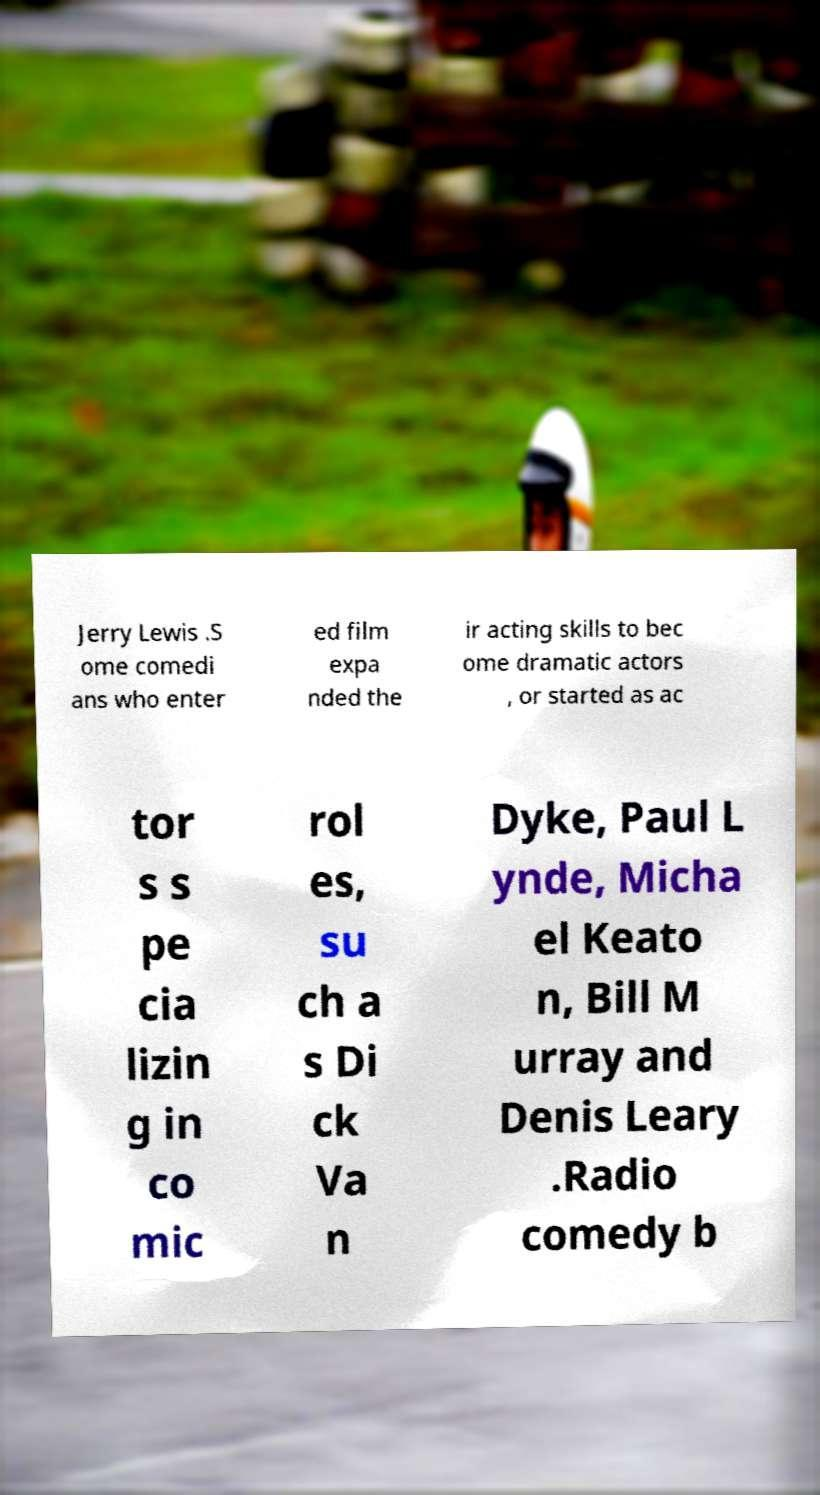Please read and relay the text visible in this image. What does it say? Jerry Lewis .S ome comedi ans who enter ed film expa nded the ir acting skills to bec ome dramatic actors , or started as ac tor s s pe cia lizin g in co mic rol es, su ch a s Di ck Va n Dyke, Paul L ynde, Micha el Keato n, Bill M urray and Denis Leary .Radio comedy b 